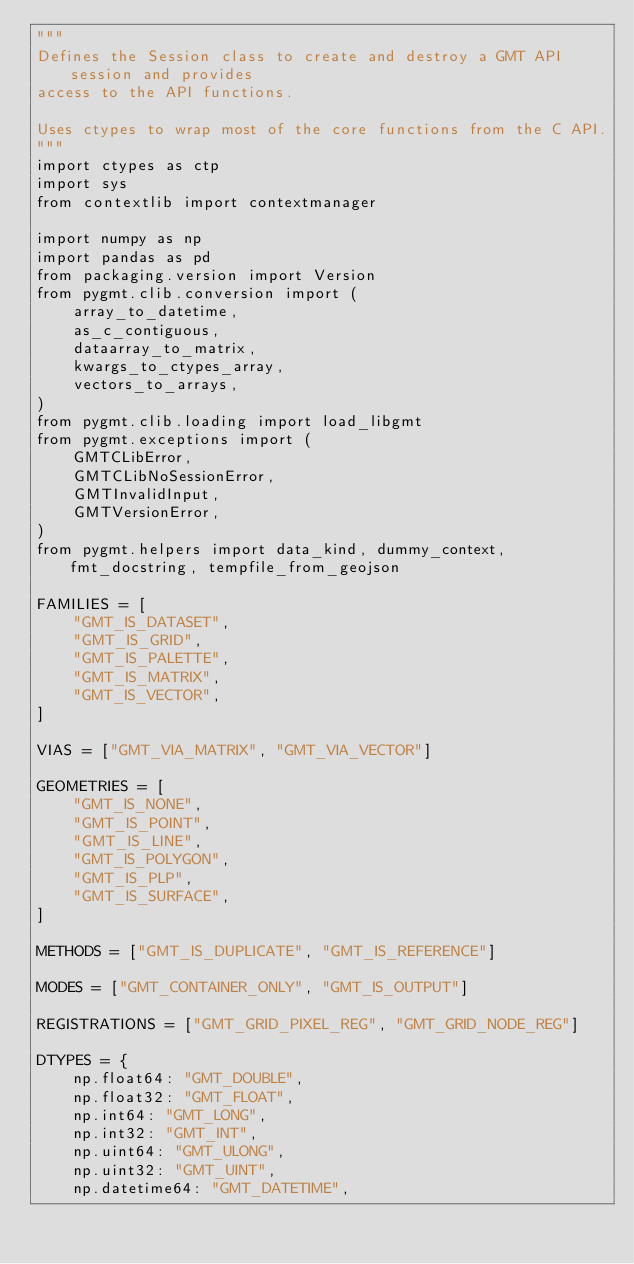<code> <loc_0><loc_0><loc_500><loc_500><_Python_>"""
Defines the Session class to create and destroy a GMT API session and provides
access to the API functions.

Uses ctypes to wrap most of the core functions from the C API.
"""
import ctypes as ctp
import sys
from contextlib import contextmanager

import numpy as np
import pandas as pd
from packaging.version import Version
from pygmt.clib.conversion import (
    array_to_datetime,
    as_c_contiguous,
    dataarray_to_matrix,
    kwargs_to_ctypes_array,
    vectors_to_arrays,
)
from pygmt.clib.loading import load_libgmt
from pygmt.exceptions import (
    GMTCLibError,
    GMTCLibNoSessionError,
    GMTInvalidInput,
    GMTVersionError,
)
from pygmt.helpers import data_kind, dummy_context, fmt_docstring, tempfile_from_geojson

FAMILIES = [
    "GMT_IS_DATASET",
    "GMT_IS_GRID",
    "GMT_IS_PALETTE",
    "GMT_IS_MATRIX",
    "GMT_IS_VECTOR",
]

VIAS = ["GMT_VIA_MATRIX", "GMT_VIA_VECTOR"]

GEOMETRIES = [
    "GMT_IS_NONE",
    "GMT_IS_POINT",
    "GMT_IS_LINE",
    "GMT_IS_POLYGON",
    "GMT_IS_PLP",
    "GMT_IS_SURFACE",
]

METHODS = ["GMT_IS_DUPLICATE", "GMT_IS_REFERENCE"]

MODES = ["GMT_CONTAINER_ONLY", "GMT_IS_OUTPUT"]

REGISTRATIONS = ["GMT_GRID_PIXEL_REG", "GMT_GRID_NODE_REG"]

DTYPES = {
    np.float64: "GMT_DOUBLE",
    np.float32: "GMT_FLOAT",
    np.int64: "GMT_LONG",
    np.int32: "GMT_INT",
    np.uint64: "GMT_ULONG",
    np.uint32: "GMT_UINT",
    np.datetime64: "GMT_DATETIME",</code> 